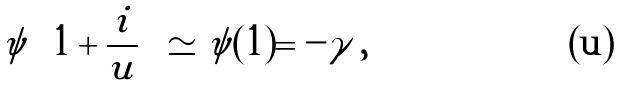<formula> <loc_0><loc_0><loc_500><loc_500>\psi \left ( 1 + \frac { i } { u } \right ) \simeq \psi ( 1 ) = - \gamma \, ,</formula> 